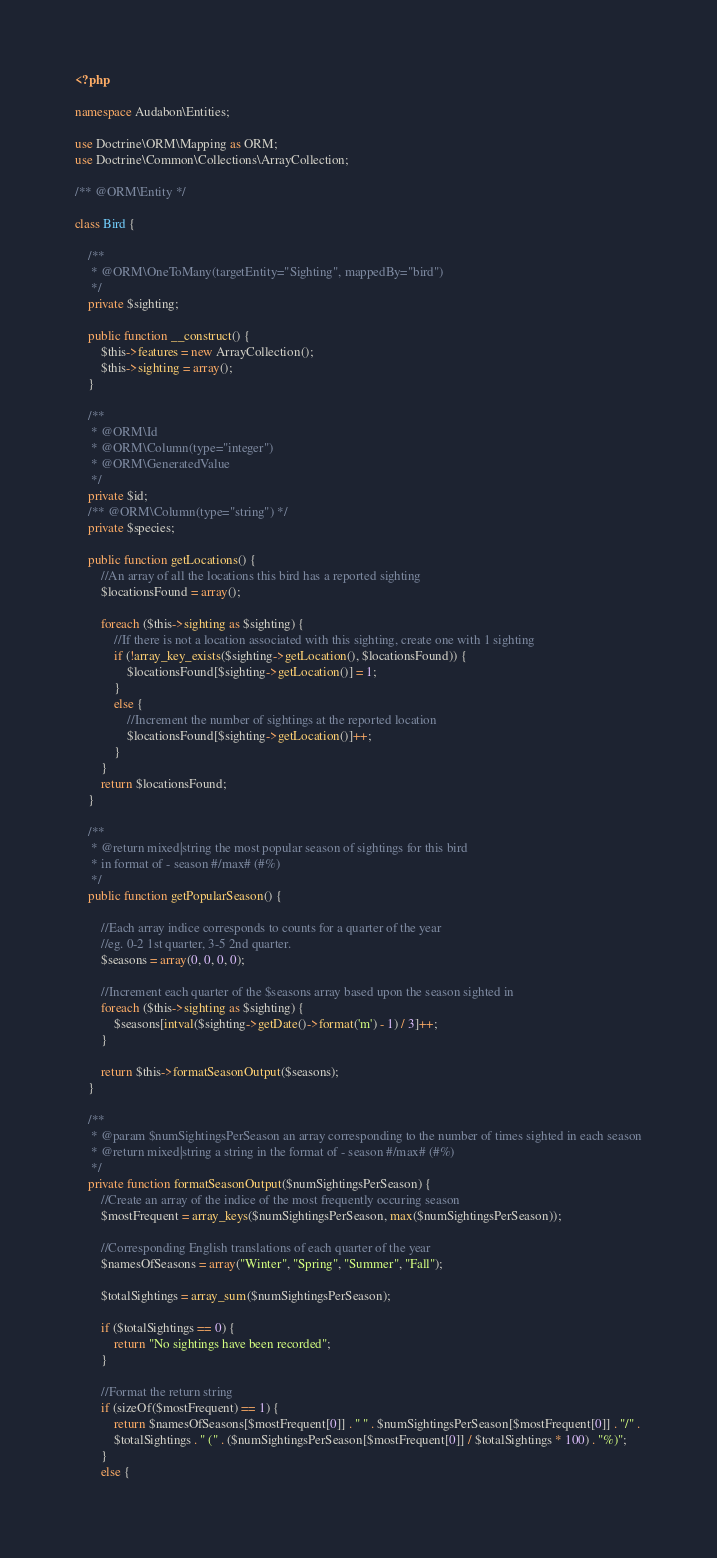<code> <loc_0><loc_0><loc_500><loc_500><_PHP_><?php

namespace Audabon\Entities;

use Doctrine\ORM\Mapping as ORM;
use Doctrine\Common\Collections\ArrayCollection;

/** @ORM\Entity */

class Bird {

    /**
     * @ORM\OneToMany(targetEntity="Sighting", mappedBy="bird")
     */
    private $sighting;

    public function __construct() {
        $this->features = new ArrayCollection();
        $this->sighting = array();
    }

    /**
     * @ORM\Id
     * @ORM\Column(type="integer")
     * @ORM\GeneratedValue
     */
    private $id;
    /** @ORM\Column(type="string") */
    private $species;

    public function getLocations() {
        //An array of all the locations this bird has a reported sighting
        $locationsFound = array();

        foreach ($this->sighting as $sighting) {
            //If there is not a location associated with this sighting, create one with 1 sighting
            if (!array_key_exists($sighting->getLocation(), $locationsFound)) {
                $locationsFound[$sighting->getLocation()] = 1;
            }
            else {
                //Increment the number of sightings at the reported location
                $locationsFound[$sighting->getLocation()]++;
            }
        }
        return $locationsFound;
    }

    /**
     * @return mixed|string the most popular season of sightings for this bird
     * in format of - season #/max# (#%)
     */
    public function getPopularSeason() {

        //Each array indice corresponds to counts for a quarter of the year
        //eg. 0-2 1st quarter, 3-5 2nd quarter.
        $seasons = array(0, 0, 0, 0);

        //Increment each quarter of the $seasons array based upon the season sighted in
        foreach ($this->sighting as $sighting) {
            $seasons[intval($sighting->getDate()->format('m') - 1) / 3]++;
        }

        return $this->formatSeasonOutput($seasons);
    }

    /**
     * @param $numSightingsPerSeason an array corresponding to the number of times sighted in each season
     * @return mixed|string a string in the format of - season #/max# (#%)
     */
    private function formatSeasonOutput($numSightingsPerSeason) {
        //Create an array of the indice of the most frequently occuring season
        $mostFrequent = array_keys($numSightingsPerSeason, max($numSightingsPerSeason));

        //Corresponding English translations of each quarter of the year
        $namesOfSeasons = array("Winter", "Spring", "Summer", "Fall");

        $totalSightings = array_sum($numSightingsPerSeason);

        if ($totalSightings == 0) {
            return "No sightings have been recorded";
        }

        //Format the return string
        if (sizeOf($mostFrequent) == 1) {
            return $namesOfSeasons[$mostFrequent[0]] . " " . $numSightingsPerSeason[$mostFrequent[0]] . "/" .
            $totalSightings . " (" . ($numSightingsPerSeason[$mostFrequent[0]] / $totalSightings * 100) . "%)";
        }
        else {</code> 